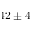<formula> <loc_0><loc_0><loc_500><loc_500>4 2 \pm 4</formula> 